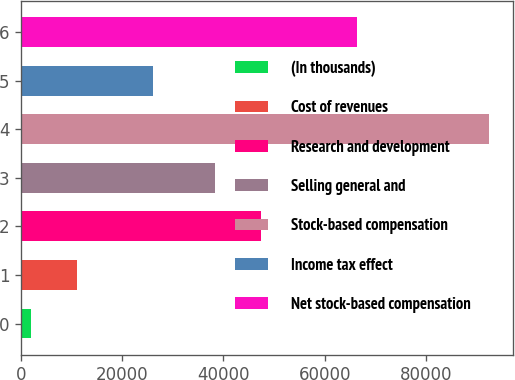<chart> <loc_0><loc_0><loc_500><loc_500><bar_chart><fcel>(In thousands)<fcel>Cost of revenues<fcel>Research and development<fcel>Selling general and<fcel>Stock-based compensation<fcel>Income tax effect<fcel>Net stock-based compensation<nl><fcel>2007<fcel>11056.4<fcel>47386.4<fcel>38337<fcel>92501<fcel>26183<fcel>66318<nl></chart> 